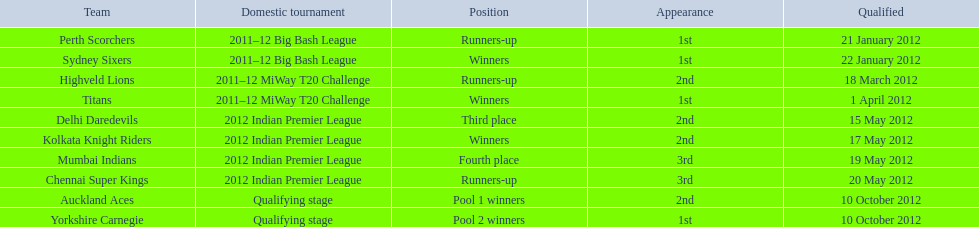What is the total number of teams that qualified? 10. Can you parse all the data within this table? {'header': ['Team', 'Domestic tournament', 'Position', 'Appearance', 'Qualified'], 'rows': [['Perth Scorchers', '2011–12 Big Bash League', 'Runners-up', '1st', '21 January 2012'], ['Sydney Sixers', '2011–12 Big Bash League', 'Winners', '1st', '22 January 2012'], ['Highveld Lions', '2011–12 MiWay T20 Challenge', 'Runners-up', '2nd', '18 March 2012'], ['Titans', '2011–12 MiWay T20 Challenge', 'Winners', '1st', '1 April 2012'], ['Delhi Daredevils', '2012 Indian Premier League', 'Third place', '2nd', '15 May 2012'], ['Kolkata Knight Riders', '2012 Indian Premier League', 'Winners', '2nd', '17 May 2012'], ['Mumbai Indians', '2012 Indian Premier League', 'Fourth place', '3rd', '19 May 2012'], ['Chennai Super Kings', '2012 Indian Premier League', 'Runners-up', '3rd', '20 May 2012'], ['Auckland Aces', 'Qualifying stage', 'Pool 1 winners', '2nd', '10 October 2012'], ['Yorkshire Carnegie', 'Qualifying stage', 'Pool 2 winners', '1st', '10 October 2012']]} 